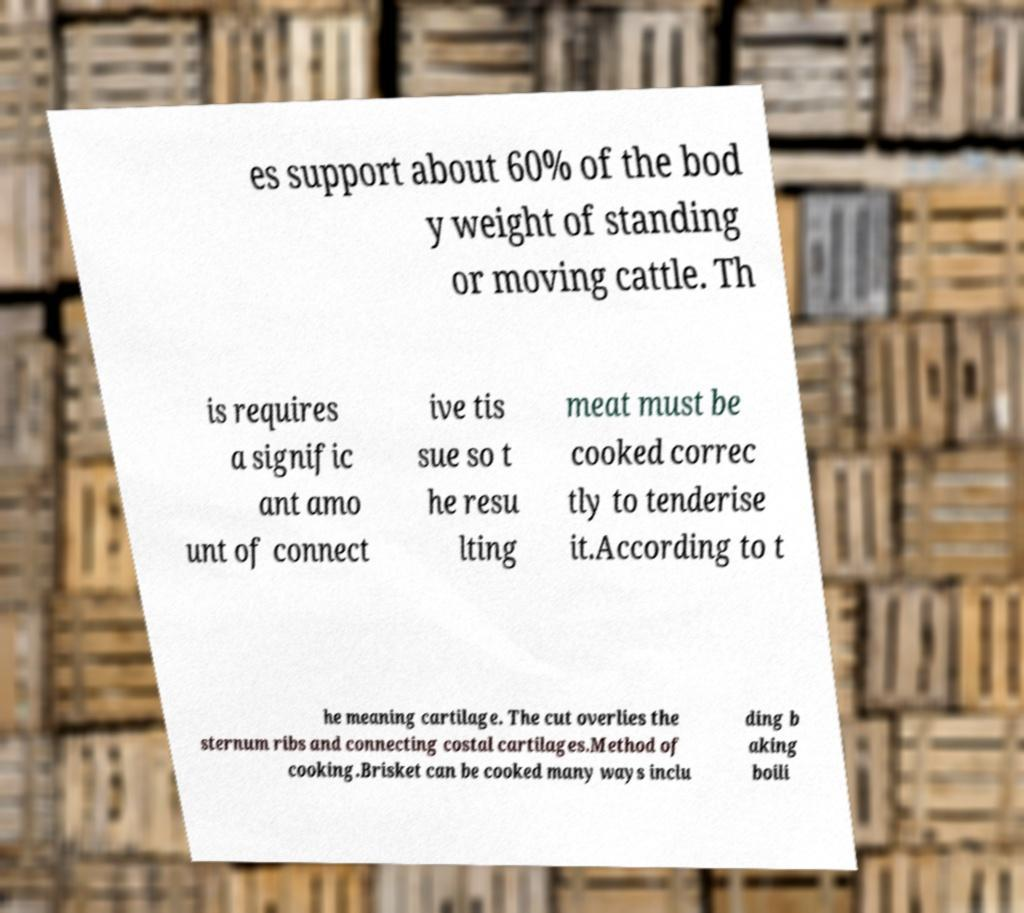What messages or text are displayed in this image? I need them in a readable, typed format. es support about 60% of the bod y weight of standing or moving cattle. Th is requires a signific ant amo unt of connect ive tis sue so t he resu lting meat must be cooked correc tly to tenderise it.According to t he meaning cartilage. The cut overlies the sternum ribs and connecting costal cartilages.Method of cooking.Brisket can be cooked many ways inclu ding b aking boili 